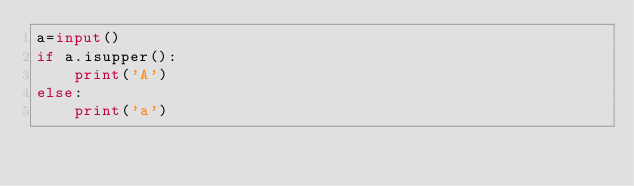<code> <loc_0><loc_0><loc_500><loc_500><_Python_>a=input()
if a.isupper():
    print('A')
else:
    print('a')</code> 